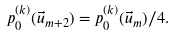Convert formula to latex. <formula><loc_0><loc_0><loc_500><loc_500>p _ { 0 } ^ { ( k ) } ( \vec { u } _ { m + 2 } ) = p _ { 0 } ^ { ( k ) } ( \vec { u } _ { m } ) / 4 .</formula> 